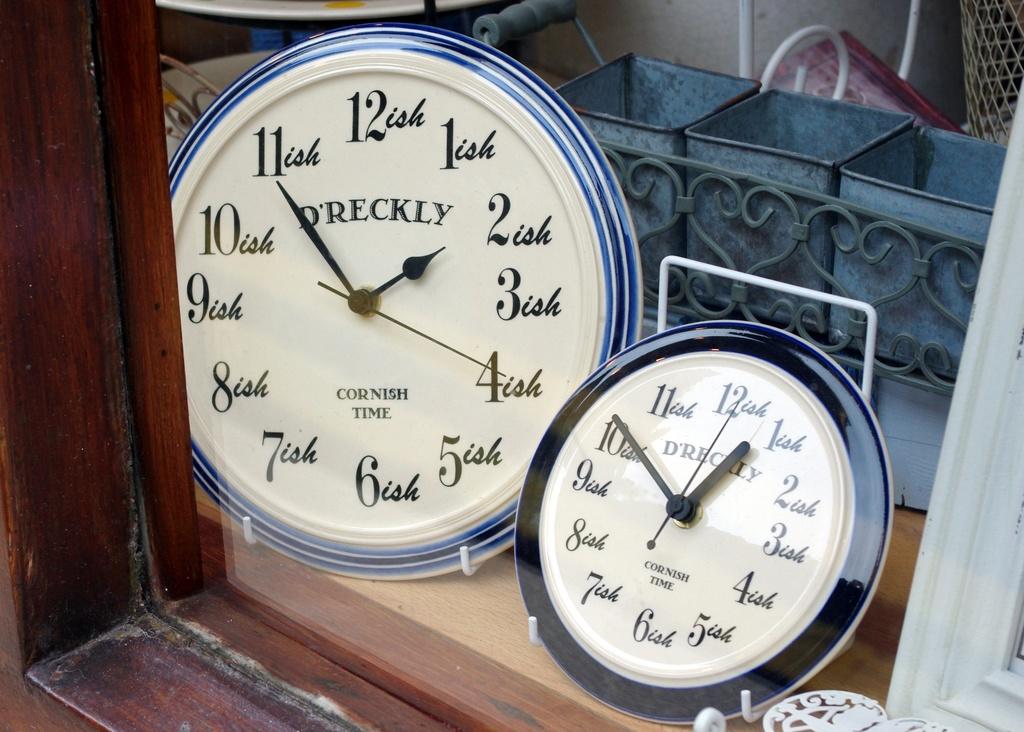What word comes just before time on the clocks?
Make the answer very short. Cornish. What time do the clocks show?
Make the answer very short. 1:55 and 12:50. 